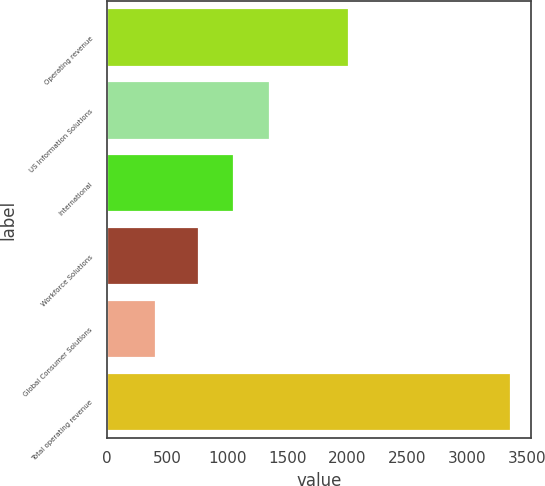Convert chart to OTSL. <chart><loc_0><loc_0><loc_500><loc_500><bar_chart><fcel>Operating revenue<fcel>US Information Solutions<fcel>International<fcel>Workforce Solutions<fcel>Global Consumer Solutions<fcel>Total operating revenue<nl><fcel>2017<fcel>1356.04<fcel>1060.12<fcel>764.2<fcel>403<fcel>3362.2<nl></chart> 